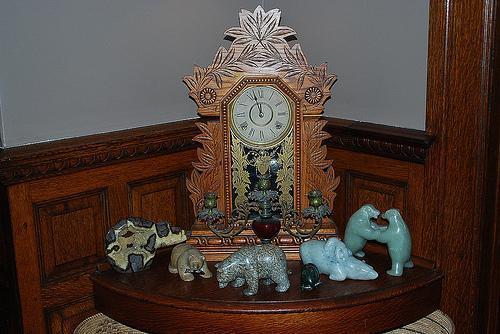How many clocks are there?
Give a very brief answer. 1. 